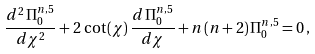<formula> <loc_0><loc_0><loc_500><loc_500>\frac { d ^ { 2 } \, \Pi ^ { n , 5 } _ { 0 } } { d \chi ^ { 2 } } + 2 \, \cot ( \chi ) \, \frac { d \, \Pi ^ { n , 5 } _ { 0 } } { d \chi } + n \, ( n + 2 ) \, \Pi ^ { n , 5 } _ { 0 } = 0 \, ,</formula> 